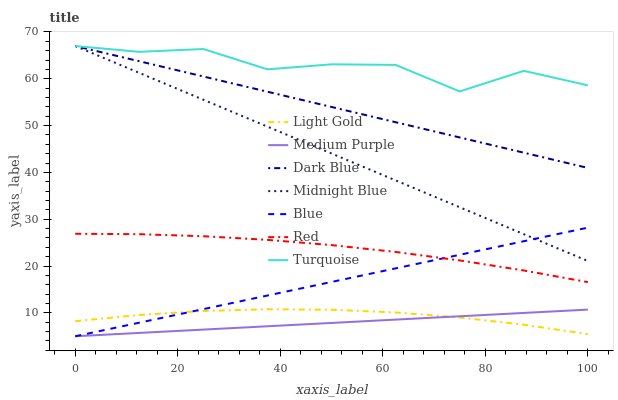Does Medium Purple have the minimum area under the curve?
Answer yes or no. Yes. Does Turquoise have the maximum area under the curve?
Answer yes or no. Yes. Does Midnight Blue have the minimum area under the curve?
Answer yes or no. No. Does Midnight Blue have the maximum area under the curve?
Answer yes or no. No. Is Blue the smoothest?
Answer yes or no. Yes. Is Turquoise the roughest?
Answer yes or no. Yes. Is Midnight Blue the smoothest?
Answer yes or no. No. Is Midnight Blue the roughest?
Answer yes or no. No. Does Blue have the lowest value?
Answer yes or no. Yes. Does Midnight Blue have the lowest value?
Answer yes or no. No. Does Dark Blue have the highest value?
Answer yes or no. Yes. Does Medium Purple have the highest value?
Answer yes or no. No. Is Light Gold less than Red?
Answer yes or no. Yes. Is Dark Blue greater than Medium Purple?
Answer yes or no. Yes. Does Midnight Blue intersect Blue?
Answer yes or no. Yes. Is Midnight Blue less than Blue?
Answer yes or no. No. Is Midnight Blue greater than Blue?
Answer yes or no. No. Does Light Gold intersect Red?
Answer yes or no. No. 